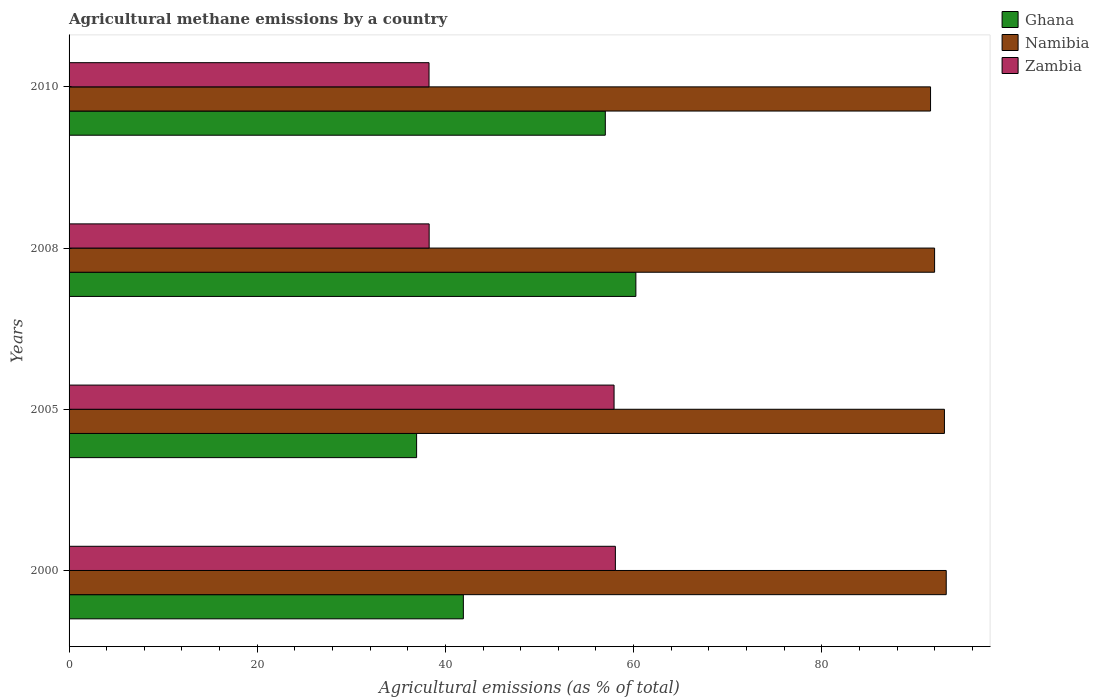How many different coloured bars are there?
Give a very brief answer. 3. How many groups of bars are there?
Provide a short and direct response. 4. Are the number of bars on each tick of the Y-axis equal?
Provide a short and direct response. Yes. How many bars are there on the 4th tick from the top?
Make the answer very short. 3. What is the amount of agricultural methane emitted in Ghana in 2000?
Your answer should be compact. 41.9. Across all years, what is the maximum amount of agricultural methane emitted in Ghana?
Ensure brevity in your answer.  60.24. Across all years, what is the minimum amount of agricultural methane emitted in Zambia?
Make the answer very short. 38.26. In which year was the amount of agricultural methane emitted in Zambia maximum?
Provide a succinct answer. 2000. What is the total amount of agricultural methane emitted in Ghana in the graph?
Offer a terse response. 196.07. What is the difference between the amount of agricultural methane emitted in Zambia in 2000 and that in 2005?
Give a very brief answer. 0.14. What is the difference between the amount of agricultural methane emitted in Zambia in 2010 and the amount of agricultural methane emitted in Namibia in 2008?
Make the answer very short. -53.73. What is the average amount of agricultural methane emitted in Zambia per year?
Provide a succinct answer. 48.13. In the year 2000, what is the difference between the amount of agricultural methane emitted in Zambia and amount of agricultural methane emitted in Namibia?
Give a very brief answer. -35.16. What is the ratio of the amount of agricultural methane emitted in Namibia in 2005 to that in 2008?
Offer a very short reply. 1.01. Is the amount of agricultural methane emitted in Zambia in 2000 less than that in 2005?
Offer a very short reply. No. Is the difference between the amount of agricultural methane emitted in Zambia in 2000 and 2010 greater than the difference between the amount of agricultural methane emitted in Namibia in 2000 and 2010?
Offer a terse response. Yes. What is the difference between the highest and the second highest amount of agricultural methane emitted in Zambia?
Offer a very short reply. 0.14. What is the difference between the highest and the lowest amount of agricultural methane emitted in Namibia?
Make the answer very short. 1.67. In how many years, is the amount of agricultural methane emitted in Zambia greater than the average amount of agricultural methane emitted in Zambia taken over all years?
Make the answer very short. 2. What does the 2nd bar from the top in 2008 represents?
Offer a very short reply. Namibia. What does the 2nd bar from the bottom in 2010 represents?
Your answer should be compact. Namibia. Where does the legend appear in the graph?
Make the answer very short. Top right. What is the title of the graph?
Offer a terse response. Agricultural methane emissions by a country. What is the label or title of the X-axis?
Offer a terse response. Agricultural emissions (as % of total). What is the Agricultural emissions (as % of total) in Ghana in 2000?
Give a very brief answer. 41.9. What is the Agricultural emissions (as % of total) of Namibia in 2000?
Your response must be concise. 93.22. What is the Agricultural emissions (as % of total) in Zambia in 2000?
Make the answer very short. 58.06. What is the Agricultural emissions (as % of total) in Ghana in 2005?
Offer a terse response. 36.94. What is the Agricultural emissions (as % of total) in Namibia in 2005?
Give a very brief answer. 93.03. What is the Agricultural emissions (as % of total) of Zambia in 2005?
Your answer should be very brief. 57.92. What is the Agricultural emissions (as % of total) of Ghana in 2008?
Give a very brief answer. 60.24. What is the Agricultural emissions (as % of total) in Namibia in 2008?
Ensure brevity in your answer.  91.99. What is the Agricultural emissions (as % of total) of Zambia in 2008?
Your answer should be very brief. 38.27. What is the Agricultural emissions (as % of total) of Ghana in 2010?
Make the answer very short. 56.99. What is the Agricultural emissions (as % of total) in Namibia in 2010?
Offer a very short reply. 91.56. What is the Agricultural emissions (as % of total) in Zambia in 2010?
Offer a very short reply. 38.26. Across all years, what is the maximum Agricultural emissions (as % of total) of Ghana?
Your response must be concise. 60.24. Across all years, what is the maximum Agricultural emissions (as % of total) of Namibia?
Provide a short and direct response. 93.22. Across all years, what is the maximum Agricultural emissions (as % of total) in Zambia?
Provide a succinct answer. 58.06. Across all years, what is the minimum Agricultural emissions (as % of total) of Ghana?
Your response must be concise. 36.94. Across all years, what is the minimum Agricultural emissions (as % of total) in Namibia?
Provide a succinct answer. 91.56. Across all years, what is the minimum Agricultural emissions (as % of total) in Zambia?
Make the answer very short. 38.26. What is the total Agricultural emissions (as % of total) of Ghana in the graph?
Keep it short and to the point. 196.07. What is the total Agricultural emissions (as % of total) of Namibia in the graph?
Provide a short and direct response. 369.8. What is the total Agricultural emissions (as % of total) in Zambia in the graph?
Offer a very short reply. 192.51. What is the difference between the Agricultural emissions (as % of total) in Ghana in 2000 and that in 2005?
Make the answer very short. 4.97. What is the difference between the Agricultural emissions (as % of total) in Namibia in 2000 and that in 2005?
Ensure brevity in your answer.  0.19. What is the difference between the Agricultural emissions (as % of total) in Zambia in 2000 and that in 2005?
Give a very brief answer. 0.14. What is the difference between the Agricultural emissions (as % of total) in Ghana in 2000 and that in 2008?
Offer a terse response. -18.34. What is the difference between the Agricultural emissions (as % of total) in Namibia in 2000 and that in 2008?
Give a very brief answer. 1.24. What is the difference between the Agricultural emissions (as % of total) in Zambia in 2000 and that in 2008?
Offer a very short reply. 19.79. What is the difference between the Agricultural emissions (as % of total) of Ghana in 2000 and that in 2010?
Keep it short and to the point. -15.09. What is the difference between the Agricultural emissions (as % of total) of Namibia in 2000 and that in 2010?
Your response must be concise. 1.67. What is the difference between the Agricultural emissions (as % of total) in Zambia in 2000 and that in 2010?
Your response must be concise. 19.8. What is the difference between the Agricultural emissions (as % of total) of Ghana in 2005 and that in 2008?
Ensure brevity in your answer.  -23.3. What is the difference between the Agricultural emissions (as % of total) of Namibia in 2005 and that in 2008?
Ensure brevity in your answer.  1.05. What is the difference between the Agricultural emissions (as % of total) of Zambia in 2005 and that in 2008?
Your answer should be very brief. 19.65. What is the difference between the Agricultural emissions (as % of total) in Ghana in 2005 and that in 2010?
Your response must be concise. -20.06. What is the difference between the Agricultural emissions (as % of total) of Namibia in 2005 and that in 2010?
Offer a very short reply. 1.48. What is the difference between the Agricultural emissions (as % of total) in Zambia in 2005 and that in 2010?
Give a very brief answer. 19.66. What is the difference between the Agricultural emissions (as % of total) of Ghana in 2008 and that in 2010?
Offer a very short reply. 3.25. What is the difference between the Agricultural emissions (as % of total) of Namibia in 2008 and that in 2010?
Offer a very short reply. 0.43. What is the difference between the Agricultural emissions (as % of total) in Zambia in 2008 and that in 2010?
Offer a very short reply. 0.01. What is the difference between the Agricultural emissions (as % of total) in Ghana in 2000 and the Agricultural emissions (as % of total) in Namibia in 2005?
Your answer should be very brief. -51.13. What is the difference between the Agricultural emissions (as % of total) of Ghana in 2000 and the Agricultural emissions (as % of total) of Zambia in 2005?
Offer a terse response. -16.02. What is the difference between the Agricultural emissions (as % of total) of Namibia in 2000 and the Agricultural emissions (as % of total) of Zambia in 2005?
Your response must be concise. 35.3. What is the difference between the Agricultural emissions (as % of total) in Ghana in 2000 and the Agricultural emissions (as % of total) in Namibia in 2008?
Give a very brief answer. -50.08. What is the difference between the Agricultural emissions (as % of total) of Ghana in 2000 and the Agricultural emissions (as % of total) of Zambia in 2008?
Your response must be concise. 3.64. What is the difference between the Agricultural emissions (as % of total) in Namibia in 2000 and the Agricultural emissions (as % of total) in Zambia in 2008?
Your answer should be very brief. 54.95. What is the difference between the Agricultural emissions (as % of total) in Ghana in 2000 and the Agricultural emissions (as % of total) in Namibia in 2010?
Provide a succinct answer. -49.65. What is the difference between the Agricultural emissions (as % of total) in Ghana in 2000 and the Agricultural emissions (as % of total) in Zambia in 2010?
Keep it short and to the point. 3.65. What is the difference between the Agricultural emissions (as % of total) of Namibia in 2000 and the Agricultural emissions (as % of total) of Zambia in 2010?
Provide a succinct answer. 54.97. What is the difference between the Agricultural emissions (as % of total) in Ghana in 2005 and the Agricultural emissions (as % of total) in Namibia in 2008?
Your answer should be very brief. -55.05. What is the difference between the Agricultural emissions (as % of total) in Ghana in 2005 and the Agricultural emissions (as % of total) in Zambia in 2008?
Your response must be concise. -1.33. What is the difference between the Agricultural emissions (as % of total) in Namibia in 2005 and the Agricultural emissions (as % of total) in Zambia in 2008?
Offer a terse response. 54.76. What is the difference between the Agricultural emissions (as % of total) of Ghana in 2005 and the Agricultural emissions (as % of total) of Namibia in 2010?
Provide a succinct answer. -54.62. What is the difference between the Agricultural emissions (as % of total) of Ghana in 2005 and the Agricultural emissions (as % of total) of Zambia in 2010?
Make the answer very short. -1.32. What is the difference between the Agricultural emissions (as % of total) of Namibia in 2005 and the Agricultural emissions (as % of total) of Zambia in 2010?
Provide a short and direct response. 54.78. What is the difference between the Agricultural emissions (as % of total) in Ghana in 2008 and the Agricultural emissions (as % of total) in Namibia in 2010?
Your answer should be compact. -31.32. What is the difference between the Agricultural emissions (as % of total) of Ghana in 2008 and the Agricultural emissions (as % of total) of Zambia in 2010?
Your answer should be compact. 21.98. What is the difference between the Agricultural emissions (as % of total) of Namibia in 2008 and the Agricultural emissions (as % of total) of Zambia in 2010?
Provide a short and direct response. 53.73. What is the average Agricultural emissions (as % of total) of Ghana per year?
Keep it short and to the point. 49.02. What is the average Agricultural emissions (as % of total) of Namibia per year?
Make the answer very short. 92.45. What is the average Agricultural emissions (as % of total) in Zambia per year?
Give a very brief answer. 48.13. In the year 2000, what is the difference between the Agricultural emissions (as % of total) in Ghana and Agricultural emissions (as % of total) in Namibia?
Provide a short and direct response. -51.32. In the year 2000, what is the difference between the Agricultural emissions (as % of total) of Ghana and Agricultural emissions (as % of total) of Zambia?
Make the answer very short. -16.16. In the year 2000, what is the difference between the Agricultural emissions (as % of total) in Namibia and Agricultural emissions (as % of total) in Zambia?
Make the answer very short. 35.16. In the year 2005, what is the difference between the Agricultural emissions (as % of total) of Ghana and Agricultural emissions (as % of total) of Namibia?
Keep it short and to the point. -56.1. In the year 2005, what is the difference between the Agricultural emissions (as % of total) of Ghana and Agricultural emissions (as % of total) of Zambia?
Your answer should be compact. -20.99. In the year 2005, what is the difference between the Agricultural emissions (as % of total) in Namibia and Agricultural emissions (as % of total) in Zambia?
Your response must be concise. 35.11. In the year 2008, what is the difference between the Agricultural emissions (as % of total) of Ghana and Agricultural emissions (as % of total) of Namibia?
Offer a very short reply. -31.75. In the year 2008, what is the difference between the Agricultural emissions (as % of total) in Ghana and Agricultural emissions (as % of total) in Zambia?
Provide a short and direct response. 21.97. In the year 2008, what is the difference between the Agricultural emissions (as % of total) in Namibia and Agricultural emissions (as % of total) in Zambia?
Offer a terse response. 53.72. In the year 2010, what is the difference between the Agricultural emissions (as % of total) in Ghana and Agricultural emissions (as % of total) in Namibia?
Your response must be concise. -34.57. In the year 2010, what is the difference between the Agricultural emissions (as % of total) in Ghana and Agricultural emissions (as % of total) in Zambia?
Your response must be concise. 18.73. In the year 2010, what is the difference between the Agricultural emissions (as % of total) in Namibia and Agricultural emissions (as % of total) in Zambia?
Offer a terse response. 53.3. What is the ratio of the Agricultural emissions (as % of total) in Ghana in 2000 to that in 2005?
Offer a terse response. 1.13. What is the ratio of the Agricultural emissions (as % of total) of Ghana in 2000 to that in 2008?
Your answer should be very brief. 0.7. What is the ratio of the Agricultural emissions (as % of total) of Namibia in 2000 to that in 2008?
Offer a terse response. 1.01. What is the ratio of the Agricultural emissions (as % of total) in Zambia in 2000 to that in 2008?
Ensure brevity in your answer.  1.52. What is the ratio of the Agricultural emissions (as % of total) in Ghana in 2000 to that in 2010?
Provide a short and direct response. 0.74. What is the ratio of the Agricultural emissions (as % of total) of Namibia in 2000 to that in 2010?
Your answer should be compact. 1.02. What is the ratio of the Agricultural emissions (as % of total) in Zambia in 2000 to that in 2010?
Your answer should be very brief. 1.52. What is the ratio of the Agricultural emissions (as % of total) of Ghana in 2005 to that in 2008?
Your answer should be very brief. 0.61. What is the ratio of the Agricultural emissions (as % of total) of Namibia in 2005 to that in 2008?
Your answer should be compact. 1.01. What is the ratio of the Agricultural emissions (as % of total) of Zambia in 2005 to that in 2008?
Offer a very short reply. 1.51. What is the ratio of the Agricultural emissions (as % of total) in Ghana in 2005 to that in 2010?
Your answer should be very brief. 0.65. What is the ratio of the Agricultural emissions (as % of total) in Namibia in 2005 to that in 2010?
Keep it short and to the point. 1.02. What is the ratio of the Agricultural emissions (as % of total) of Zambia in 2005 to that in 2010?
Ensure brevity in your answer.  1.51. What is the ratio of the Agricultural emissions (as % of total) of Ghana in 2008 to that in 2010?
Keep it short and to the point. 1.06. What is the ratio of the Agricultural emissions (as % of total) in Namibia in 2008 to that in 2010?
Provide a short and direct response. 1. What is the difference between the highest and the second highest Agricultural emissions (as % of total) of Ghana?
Give a very brief answer. 3.25. What is the difference between the highest and the second highest Agricultural emissions (as % of total) of Namibia?
Provide a short and direct response. 0.19. What is the difference between the highest and the second highest Agricultural emissions (as % of total) of Zambia?
Your answer should be very brief. 0.14. What is the difference between the highest and the lowest Agricultural emissions (as % of total) in Ghana?
Offer a very short reply. 23.3. What is the difference between the highest and the lowest Agricultural emissions (as % of total) in Namibia?
Offer a very short reply. 1.67. What is the difference between the highest and the lowest Agricultural emissions (as % of total) in Zambia?
Offer a terse response. 19.8. 